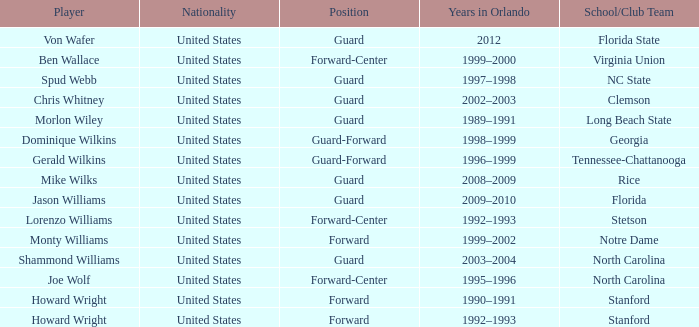Parse the full table. {'header': ['Player', 'Nationality', 'Position', 'Years in Orlando', 'School/Club Team'], 'rows': [['Von Wafer', 'United States', 'Guard', '2012', 'Florida State'], ['Ben Wallace', 'United States', 'Forward-Center', '1999–2000', 'Virginia Union'], ['Spud Webb', 'United States', 'Guard', '1997–1998', 'NC State'], ['Chris Whitney', 'United States', 'Guard', '2002–2003', 'Clemson'], ['Morlon Wiley', 'United States', 'Guard', '1989–1991', 'Long Beach State'], ['Dominique Wilkins', 'United States', 'Guard-Forward', '1998–1999', 'Georgia'], ['Gerald Wilkins', 'United States', 'Guard-Forward', '1996–1999', 'Tennessee-Chattanooga'], ['Mike Wilks', 'United States', 'Guard', '2008–2009', 'Rice'], ['Jason Williams', 'United States', 'Guard', '2009–2010', 'Florida'], ['Lorenzo Williams', 'United States', 'Forward-Center', '1992–1993', 'Stetson'], ['Monty Williams', 'United States', 'Forward', '1999–2002', 'Notre Dame'], ['Shammond Williams', 'United States', 'Guard', '2003–2004', 'North Carolina'], ['Joe Wolf', 'United States', 'Forward-Center', '1995–1996', 'North Carolina'], ['Howard Wright', 'United States', 'Forward', '1990–1991', 'Stanford'], ['Howard Wright', 'United States', 'Forward', '1992–1993', 'Stanford']]} What School/Club did Dominique Wilkins play for? Georgia. 